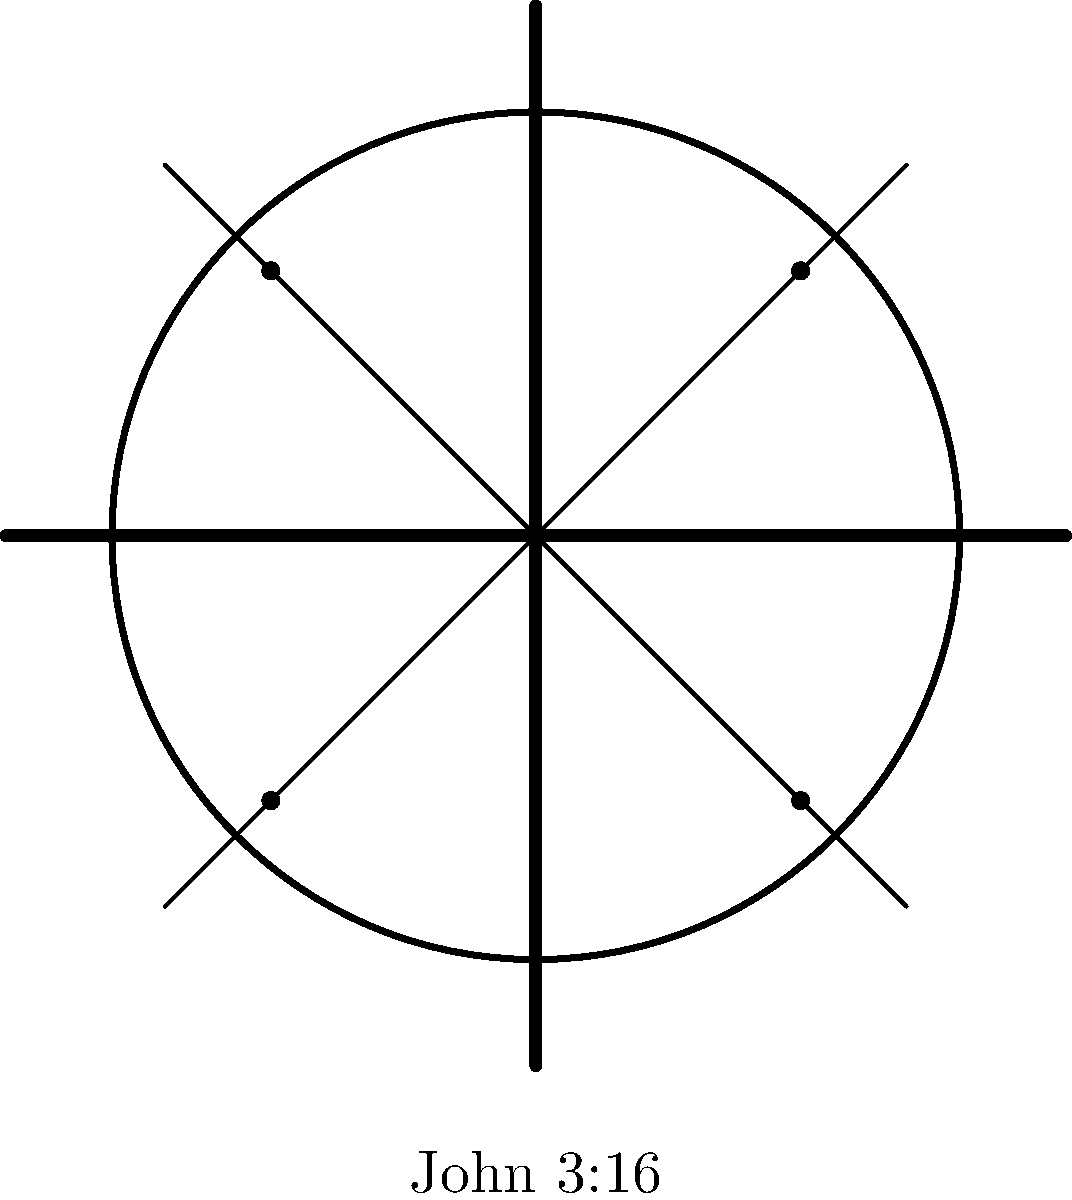In the given movie poster design, what does the combination of a cross, film reel, and the reference to John 3:16 symbolize in terms of spreading the Gospel through cinema? 1. Cross: The central cross represents the core of Christian faith, symbolizing Christ's sacrifice and redemption.

2. Film reel: This element represents the medium of movies, indicating that cinema is the focus of the poster.

3. Intersecting lines: The film strip crossing through the reel forms an "X" shape, which can be interpreted as the Greek letter Chi, often used as a symbol for Christ.

4. Four dots: These could represent the four Gospels or the four corners of the earth, suggesting the global reach of the message.

5. John 3:16: This biblical reference is often considered the essence of the Gospel message, encapsulating God's love and the promise of salvation.

6. Integration: The combination of these elements suggests using movies as a tool to spread the Gospel message globally.

7. Symbolism: The poster implies that movies can be a powerful medium to share the central Christian message of salvation and God's love, as encapsulated in John 3:16.

8. Call to action: For a religious zealot, this poster would serve as a reminder and encouragement to use cinema as a means of evangelism and sharing their faith.
Answer: Movies as a tool for global evangelism 